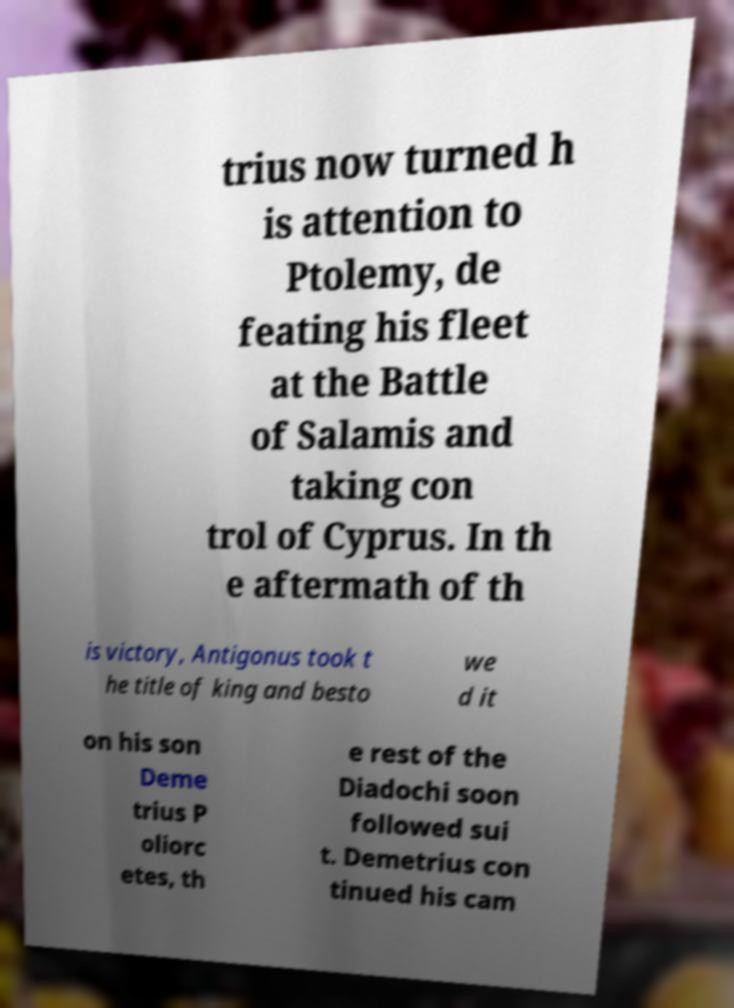Please identify and transcribe the text found in this image. trius now turned h is attention to Ptolemy, de feating his fleet at the Battle of Salamis and taking con trol of Cyprus. In th e aftermath of th is victory, Antigonus took t he title of king and besto we d it on his son Deme trius P oliorc etes, th e rest of the Diadochi soon followed sui t. Demetrius con tinued his cam 